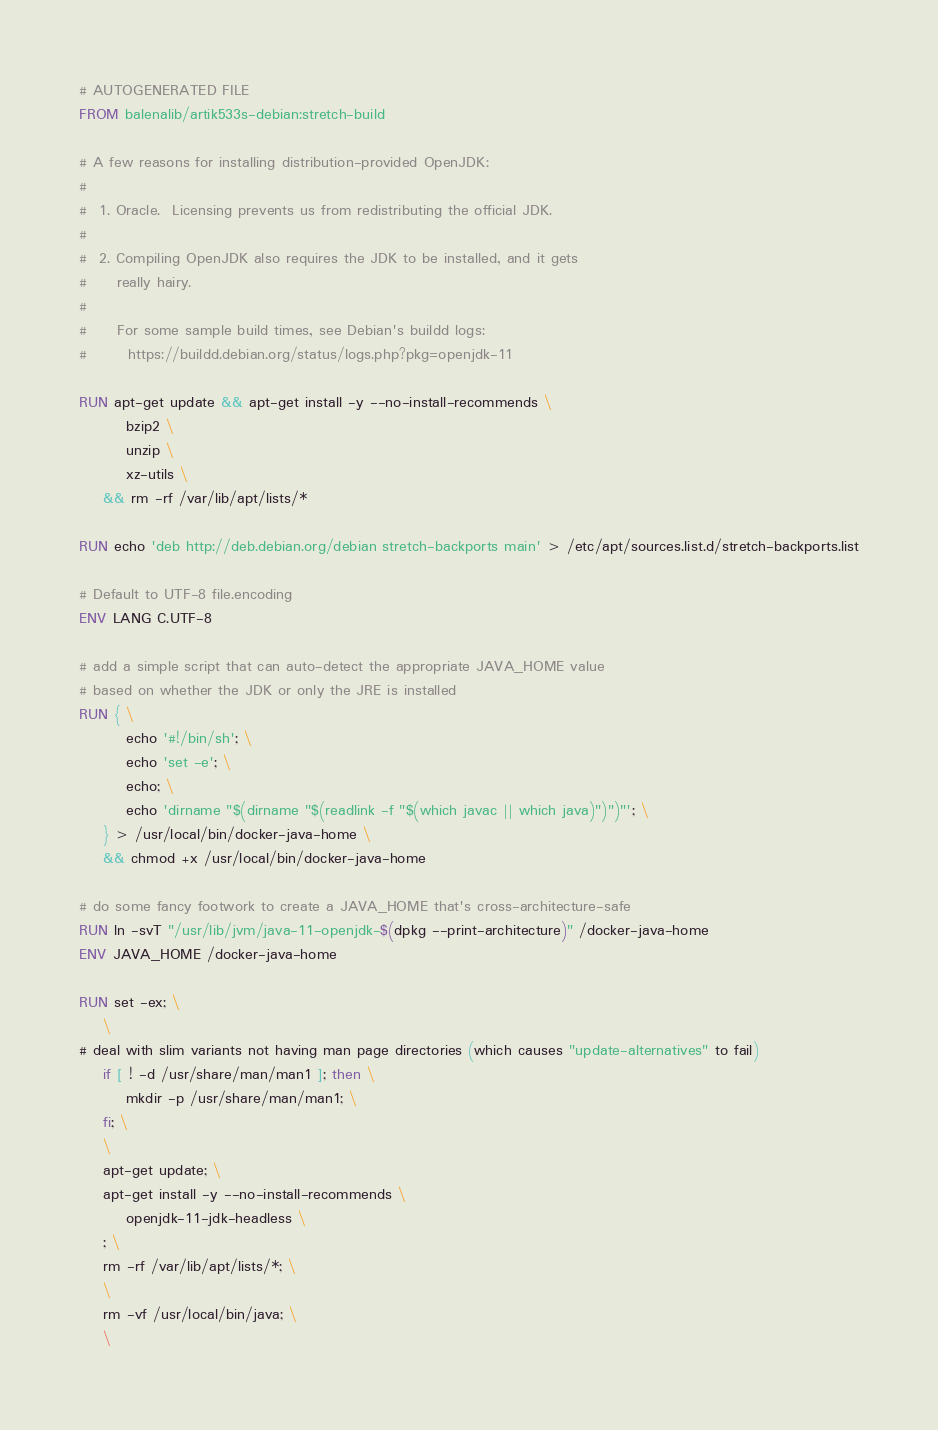<code> <loc_0><loc_0><loc_500><loc_500><_Dockerfile_># AUTOGENERATED FILE
FROM balenalib/artik533s-debian:stretch-build

# A few reasons for installing distribution-provided OpenJDK:
#
#  1. Oracle.  Licensing prevents us from redistributing the official JDK.
#
#  2. Compiling OpenJDK also requires the JDK to be installed, and it gets
#     really hairy.
#
#     For some sample build times, see Debian's buildd logs:
#       https://buildd.debian.org/status/logs.php?pkg=openjdk-11

RUN apt-get update && apt-get install -y --no-install-recommends \
		bzip2 \
		unzip \
		xz-utils \
	&& rm -rf /var/lib/apt/lists/*

RUN echo 'deb http://deb.debian.org/debian stretch-backports main' > /etc/apt/sources.list.d/stretch-backports.list

# Default to UTF-8 file.encoding
ENV LANG C.UTF-8

# add a simple script that can auto-detect the appropriate JAVA_HOME value
# based on whether the JDK or only the JRE is installed
RUN { \
		echo '#!/bin/sh'; \
		echo 'set -e'; \
		echo; \
		echo 'dirname "$(dirname "$(readlink -f "$(which javac || which java)")")"'; \
	} > /usr/local/bin/docker-java-home \
	&& chmod +x /usr/local/bin/docker-java-home

# do some fancy footwork to create a JAVA_HOME that's cross-architecture-safe
RUN ln -svT "/usr/lib/jvm/java-11-openjdk-$(dpkg --print-architecture)" /docker-java-home
ENV JAVA_HOME /docker-java-home

RUN set -ex; \
	\
# deal with slim variants not having man page directories (which causes "update-alternatives" to fail)
	if [ ! -d /usr/share/man/man1 ]; then \
		mkdir -p /usr/share/man/man1; \
	fi; \
	\
	apt-get update; \
	apt-get install -y --no-install-recommends \
		openjdk-11-jdk-headless \
	; \
	rm -rf /var/lib/apt/lists/*; \
	\
	rm -vf /usr/local/bin/java; \
	\</code> 